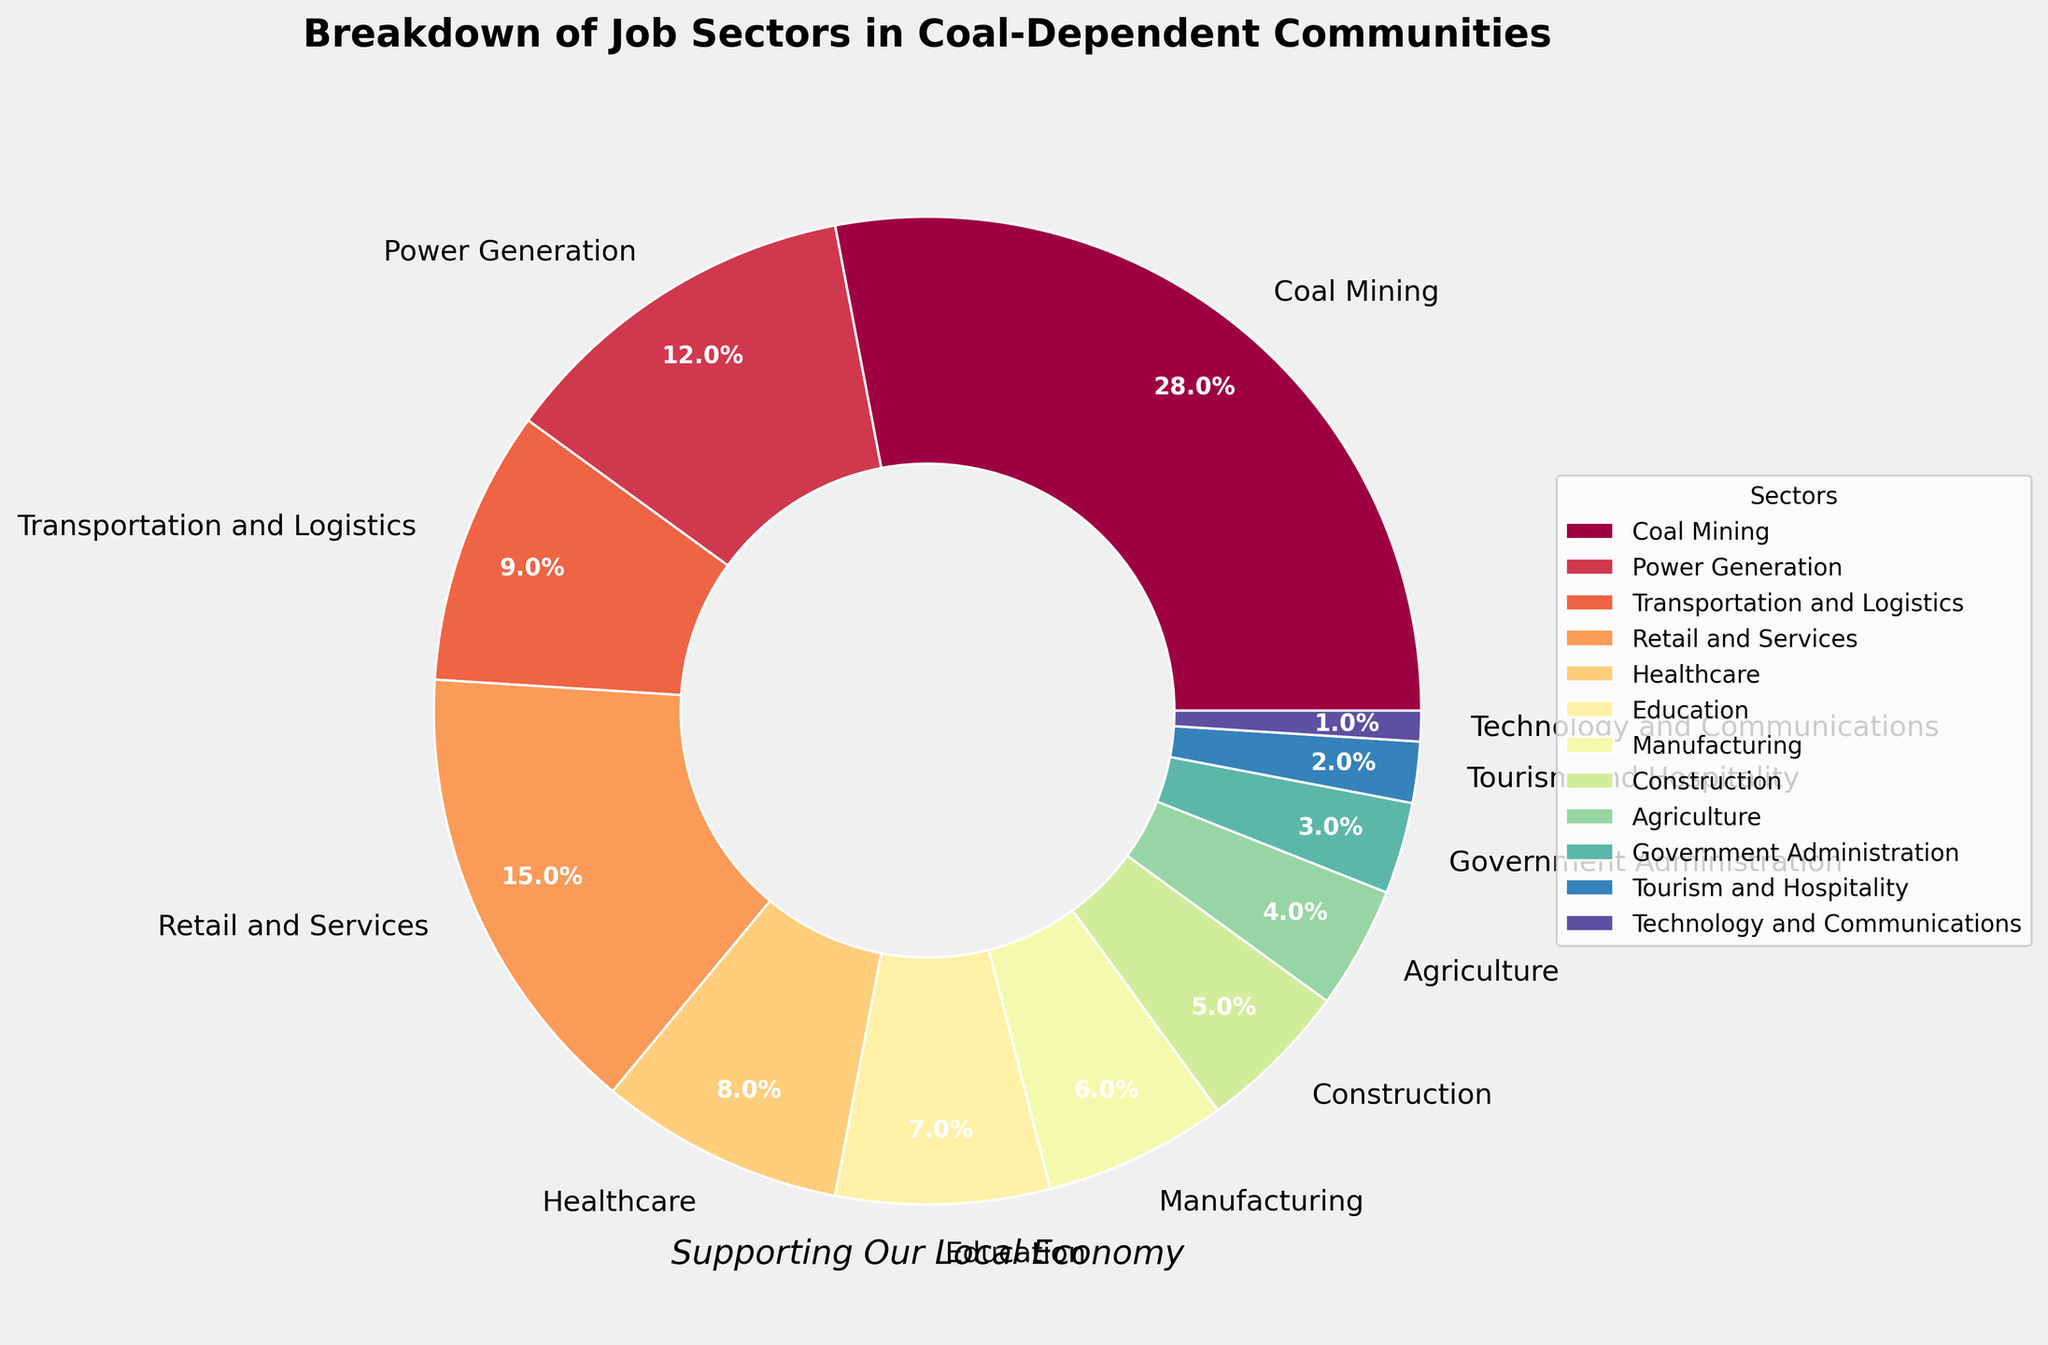What is the largest job sector in coal-dependent communities? The largest segment in the pie chart is labeled "Coal Mining" with a percentage of 28%.
Answer: Coal Mining Which job sector has a smaller percentage than Retail and Services but larger than Healthcare? Retail and Services has 15%, and Healthcare has 8%. The job sector with a percentage between these two is Transportation and Logistics at 9%.
Answer: Transportation and Logistics What is the combined percentage of Coal Mining and Power Generation? Coal Mining is 28% and Power Generation is 12%. Adding these together: 28% + 12% = 40%.
Answer: 40% How much larger is the percentage for Coal Mining compared to Manufacturing? Coal Mining is 28% and Manufacturing is 6%. The difference is 28% - 6% = 22%.
Answer: 22% Which job sector has the smallest percentage and what is it? The smallest segment in the pie chart is labeled "Technology and Communications" with a percentage of 1%.
Answer: Technology and Communications, 1% What is the total percentage for sectors related to services and retail? Retail and Services is 15%, and Tourism and Hospitality is 2%. Adding these together: 15% + 2% = 17%.
Answer: 17% How does the percentage for Education compare to Construction? Education is 7% and Construction is 5%. Therefore, Education has a larger percentage than Construction.
Answer: Education, larger Which job sectors have a combined percentage equal to that of Healthcare? Healthcare is 8%. Both Agriculture (4%) and Government Administration (3%) added together (4% + 3%) is 7%, which is slightly less than Healthcare. So, no single combination of sectors equal exactly 8%.
Answer: None What is the combined percentage of sectors with less than 10%? Adding percentages for Transportation and Logistics (9%), Healthcare (8%), Education (7%), Manufacturing (6%), Construction (5%), Agriculture (4%), Government Administration (3%), Tourism and Hospitality (2%), and Technology and Communications (1%): 9% + 8% + 7% + 6% + 5% + 4% + 3% + 2% + 1% = 45%.
Answer: 45% Which sectors have a larger percentage than Agriculture? The percentages larger than Agriculture (4%) are Coal Mining (28%), Power Generation (12%), Retail and Services (15%), Transportation and Logistics (9%), Healthcare (8%), Education (7%), and Manufacturing (6%).
Answer: Coal Mining, Power Generation, Retail and Services, Transportation and Logistics, Healthcare, Education, Manufacturing 